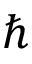<formula> <loc_0><loc_0><loc_500><loc_500>\hbar</formula> 